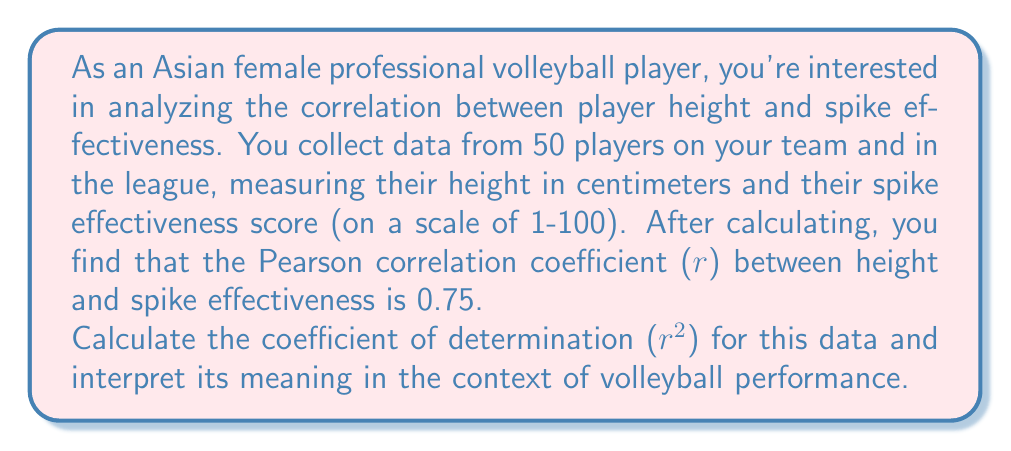Can you solve this math problem? To solve this problem, we'll follow these steps:

1. Recall the formula for the coefficient of determination:
   $$r^2 = (r)^2$$
   where $r$ is the Pearson correlation coefficient.

2. Calculate $r^2$ using the given $r$ value:
   $$r^2 = (0.75)^2 = 0.5625$$

3. Interpret the meaning of $r^2$:
   The coefficient of determination ($r^2$) represents the proportion of the variance in the dependent variable (spike effectiveness) that is predictable from the independent variable (player height).

   In this case, $r^2 = 0.5625$, which means that approximately 56.25% of the variance in spike effectiveness can be explained by the variance in player height.

Interpretation in the context of volleyball performance:
- This result suggests a moderate to strong relationship between player height and spike effectiveness.
- About 56.25% of the differences in spike effectiveness among players can be attributed to differences in their height.
- While height is an important factor in spike effectiveness, it's not the only factor. The remaining 43.75% of the variance in spike effectiveness is likely due to other factors such as technique, timing, strength, and experience.
Answer: $r^2 = 0.5625$ or 56.25%

This means that approximately 56.25% of the variance in spike effectiveness can be explained by player height in this volleyball dataset. 